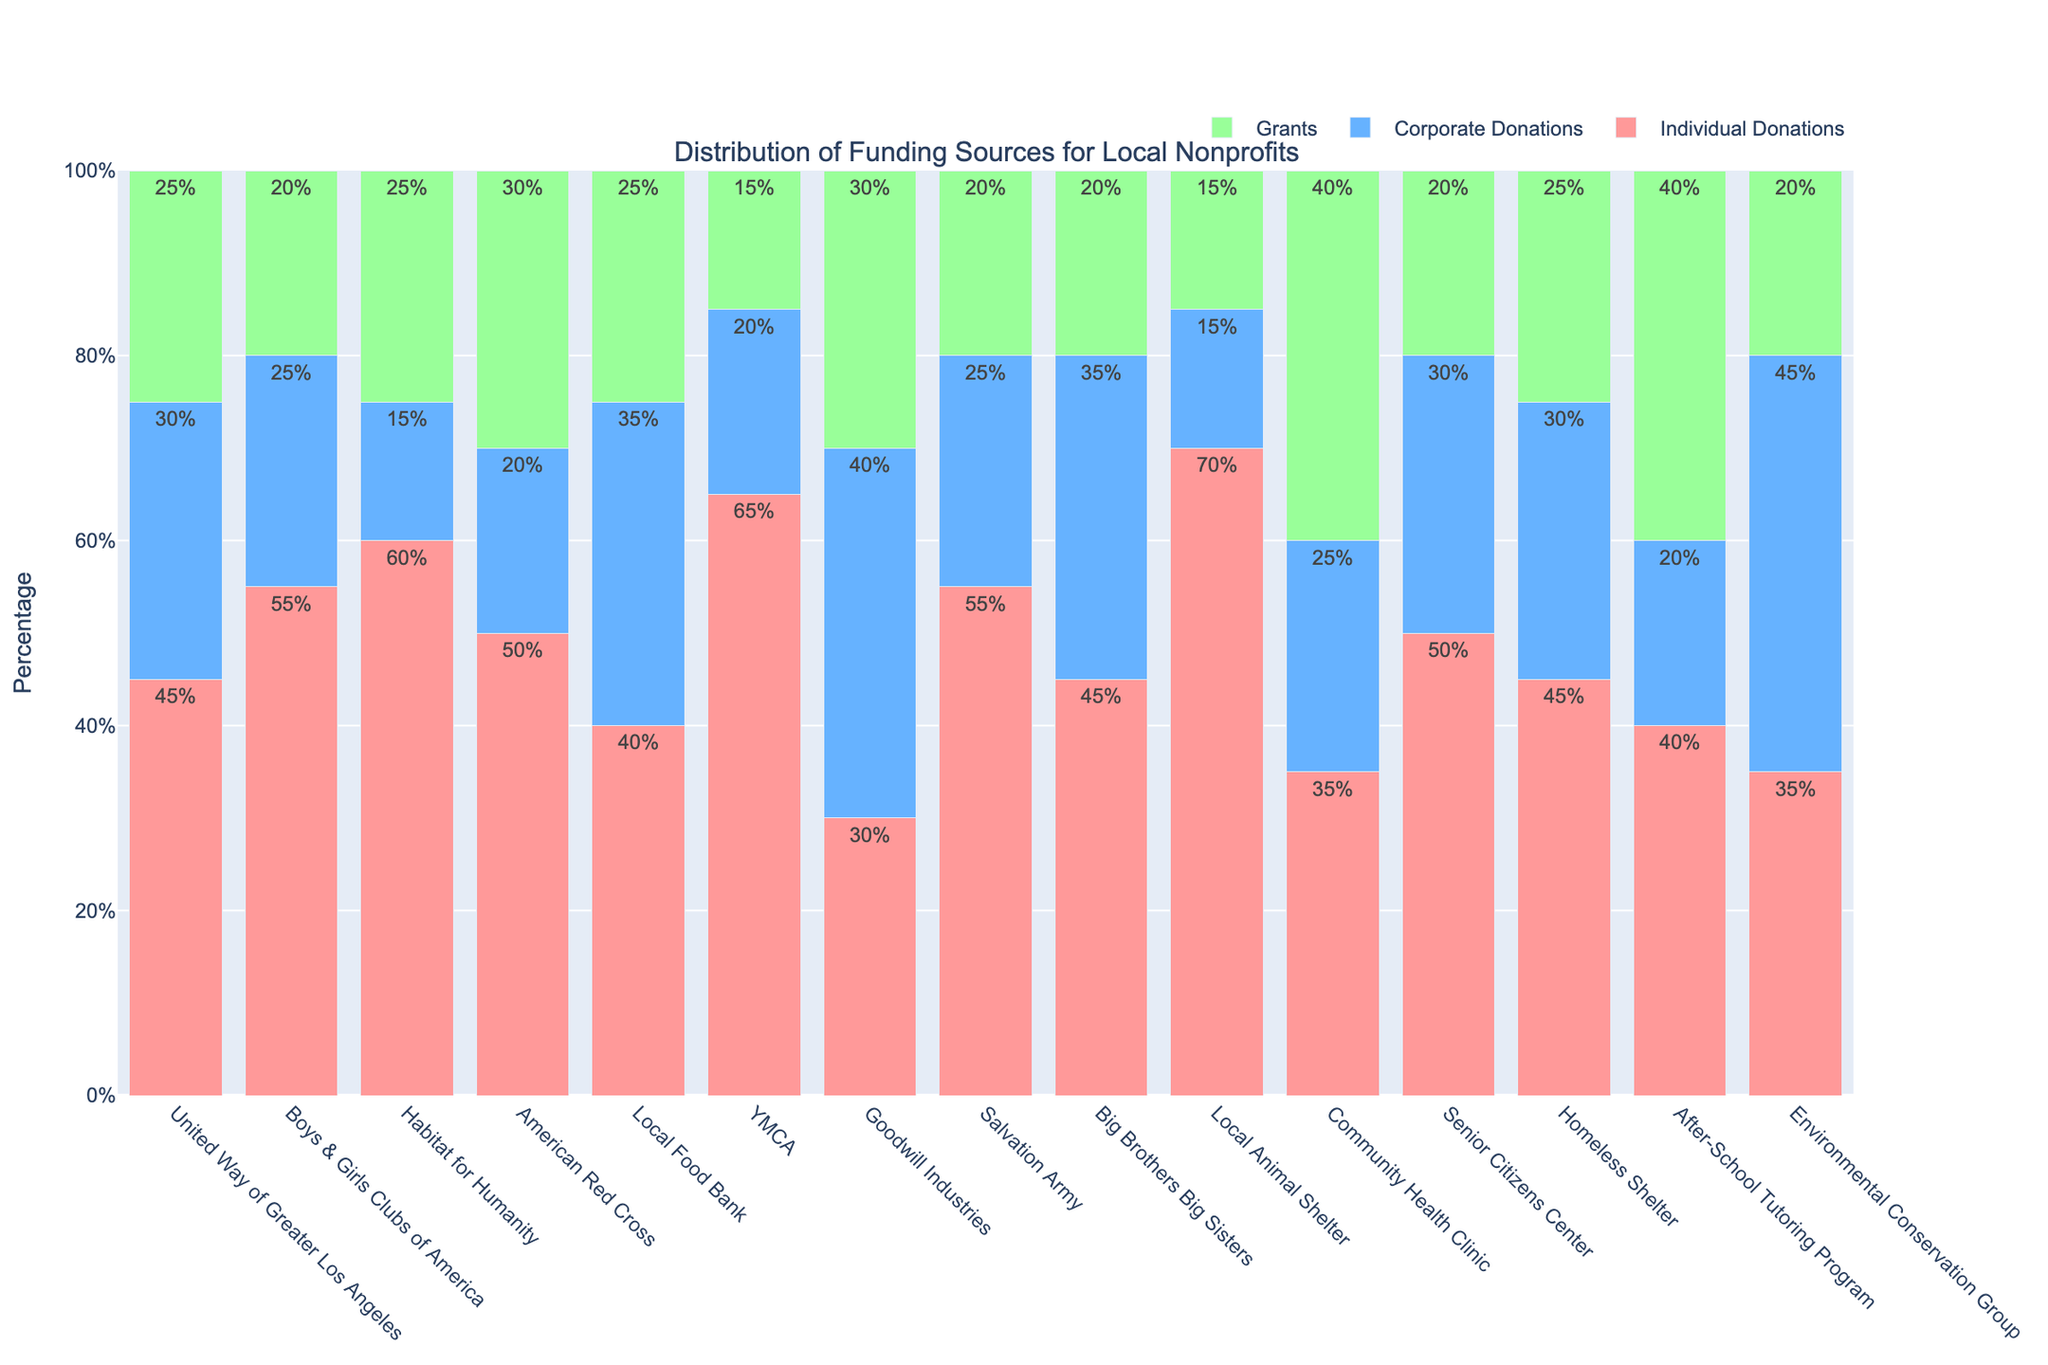What percentage of total donations does the Local Animal Shelter receive from individual donations? The Local Animal Shelter receives 70% of its total donations from individual donations. This information is directly visible in the figure under the Local Animal Shelter column for individual donations.
Answer: 70% Which organization receives the highest percentage of its funding from corporate donations? Goodwill Industries receives the highest percentage of its funding from corporate donations. This is evident from the figure where the bar representing corporate donations for Goodwill Industries is the tallest compared to other organizations.
Answer: Goodwill Industries Compare the total percentage of donations coming from grants for Community Health Clinic and After-School Tutoring Program. Which organization has a higher percentage, and by how much? The Community Health Clinic receives 40% of its total donations from grants while the After-School Tutoring Program also receives 40%. The comparison shows that both organizations receive an equal percentage from grants.
Answer: Both are equal, 40% What is the average percentage of individual donations across all organizations? To find the average percentage of individual donations, sum the individual donation percentages for all organizations and divide by the number of organizations. (45 + 55 + 60 + 50 + 40 + 65 + 30 + 55 + 45 + 70 + 35 + 50 + 45 + 40 + 35) / 15 = 645 / 15 = 43%.
Answer: 43% Which organizations receive an equal percentage of their funding from individual and corporate donations? Organizations that receive an equal percentage of their funding from individual and corporate donations are not visible as per the figure provided. All organizations have different percentage values for individual and corporate donations.
Answer: None By how much does the percentage of corporate donations for the Local Food Bank exceed that for the YMCA? The Local Food Bank receives 35% of its funding from corporate donations, while the YMCA receives 20%. The difference is 35% - 20% = 15%.
Answer: 15% Which funding source contributes the most to the American Red Cross? Individual donations contribute the most to the American Red Cross. This is determined by observing the highest bar segment for the American Red Cross, which corresponds to individual donations at 50%.
Answer: Individual donations How does the total percentage of corporate and grant donations combined for the United Way of Greater Los Angeles compare to individual donations for the same organization? The total percentage of corporate and grant donations combined for the United Way of Greater Los Angeles is 30% + 25% = 55%. Individual donations are 45%. Comparison shows that the combined percentage of corporate and grants (55%) is higher than individual donations (45%) by 10%.
Answer: 10% What is the percentage difference between individual donations for Big Brothers Big Sisters and Local Animal Shelter? Individual donations for Big Brothers Big Sisters are 45% while for the Local Animal Shelter it's 70%. The difference is 70% - 45% = 25%.
Answer: 25% 